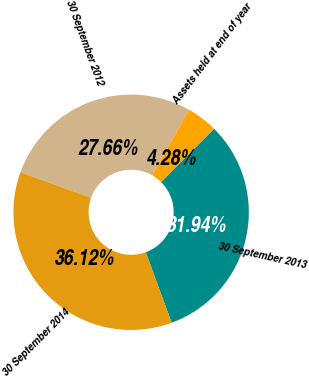<chart> <loc_0><loc_0><loc_500><loc_500><pie_chart><fcel>30 September 2012<fcel>Assets held at end of year<fcel>30 September 2013<fcel>30 September 2014<nl><fcel>27.66%<fcel>4.28%<fcel>31.94%<fcel>36.12%<nl></chart> 